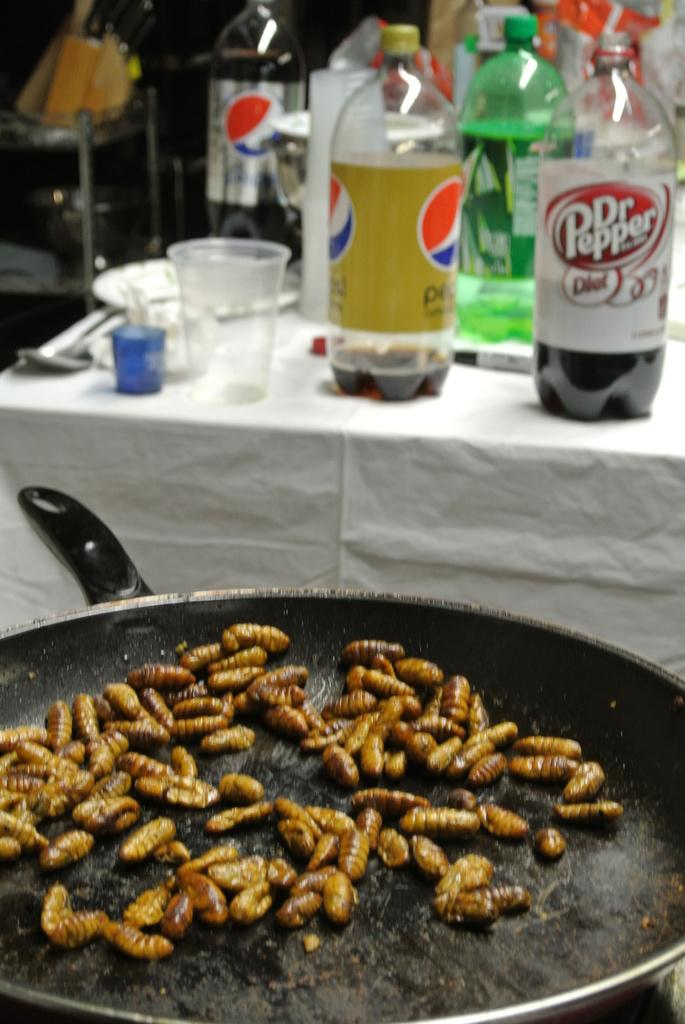Provide a one-sentence caption for the provided image. Bugs are cooking in a frying pan, and many bottles of soda, including Dr. Pepper, are on the table behind. 